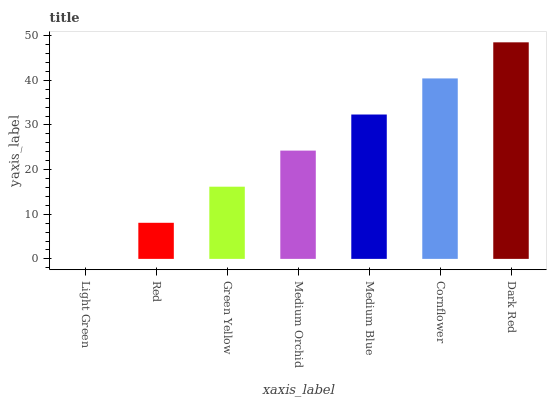Is Light Green the minimum?
Answer yes or no. Yes. Is Dark Red the maximum?
Answer yes or no. Yes. Is Red the minimum?
Answer yes or no. No. Is Red the maximum?
Answer yes or no. No. Is Red greater than Light Green?
Answer yes or no. Yes. Is Light Green less than Red?
Answer yes or no. Yes. Is Light Green greater than Red?
Answer yes or no. No. Is Red less than Light Green?
Answer yes or no. No. Is Medium Orchid the high median?
Answer yes or no. Yes. Is Medium Orchid the low median?
Answer yes or no. Yes. Is Cornflower the high median?
Answer yes or no. No. Is Cornflower the low median?
Answer yes or no. No. 